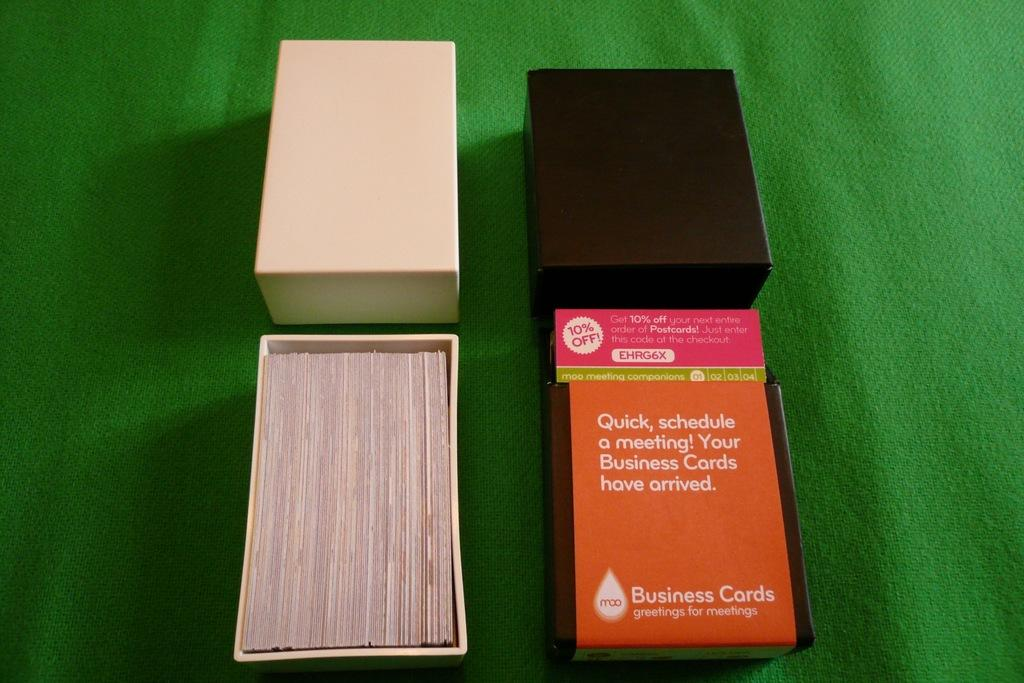Provide a one-sentence caption for the provided image. Business card boxes are shown on a green setting designed at moo. 